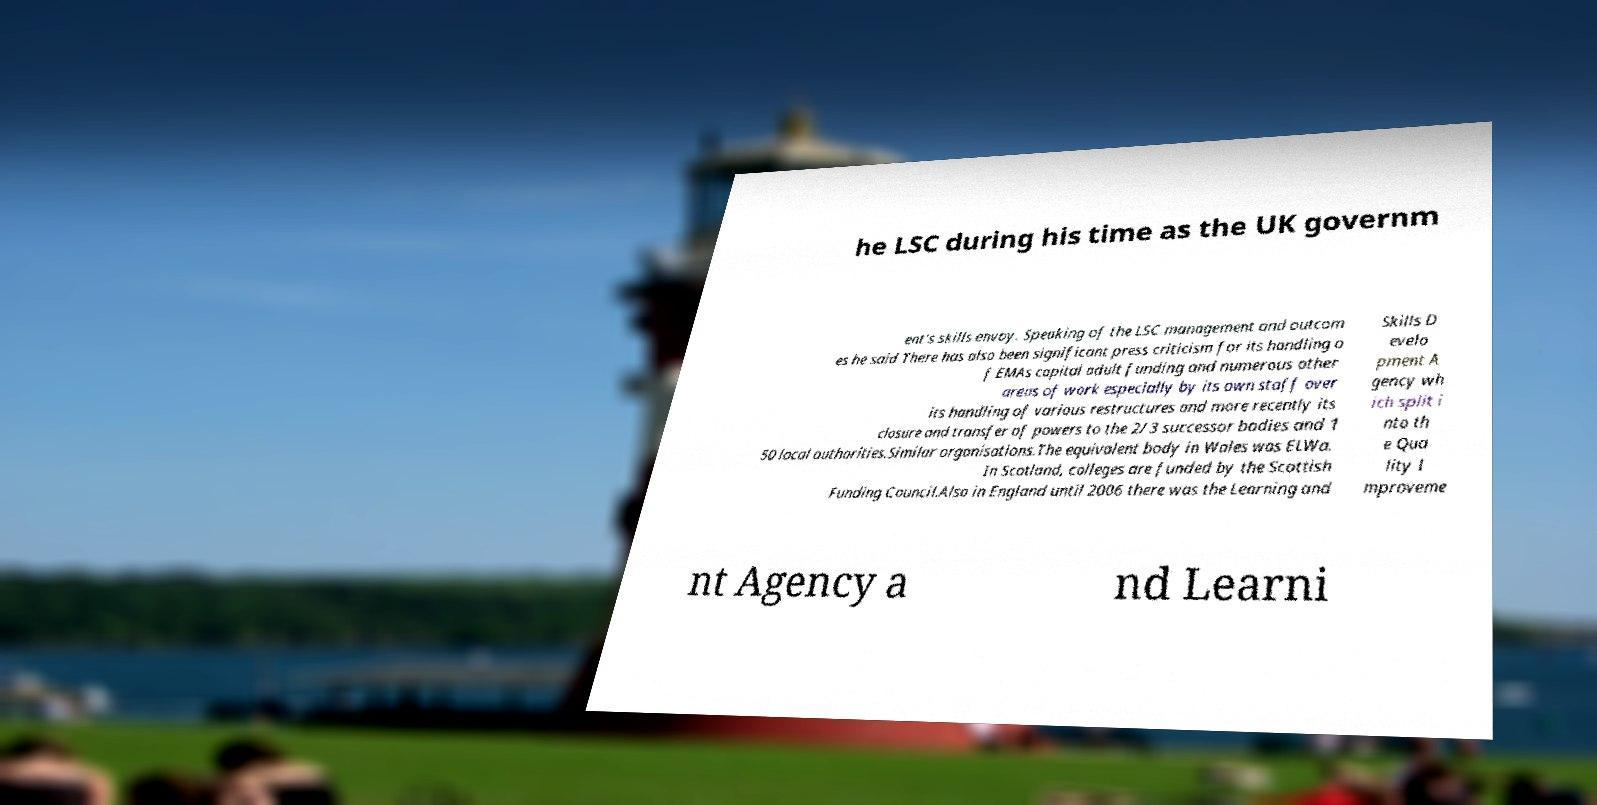Could you extract and type out the text from this image? he LSC during his time as the UK governm ent's skills envoy. Speaking of the LSC management and outcom es he said There has also been significant press criticism for its handling o f EMAs capital adult funding and numerous other areas of work especially by its own staff over its handling of various restructures and more recently its closure and transfer of powers to the 2/3 successor bodies and 1 50 local authorities.Similar organisations.The equivalent body in Wales was ELWa. In Scotland, colleges are funded by the Scottish Funding Council.Also in England until 2006 there was the Learning and Skills D evelo pment A gency wh ich split i nto th e Qua lity I mproveme nt Agency a nd Learni 